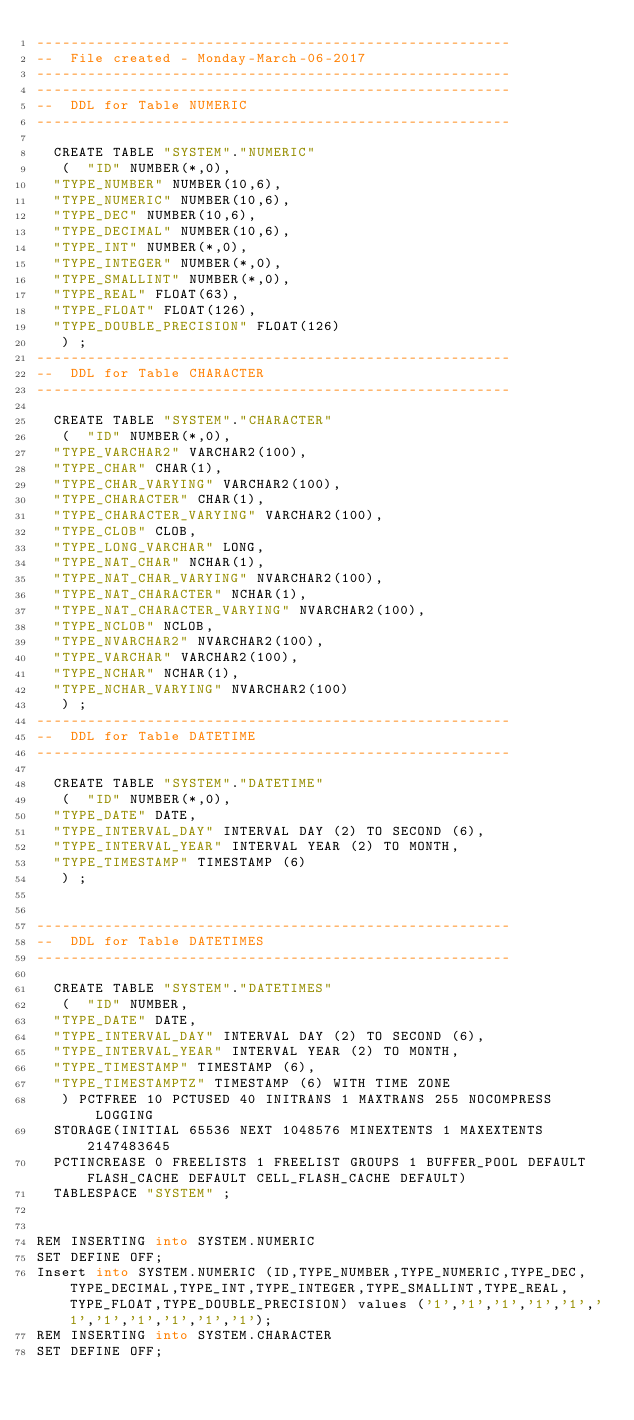<code> <loc_0><loc_0><loc_500><loc_500><_SQL_>--------------------------------------------------------
--  File created - Monday-March-06-2017   
--------------------------------------------------------
--------------------------------------------------------
--  DDL for Table NUMERIC
--------------------------------------------------------

  CREATE TABLE "SYSTEM"."NUMERIC" 
   (	"ID" NUMBER(*,0), 
	"TYPE_NUMBER" NUMBER(10,6), 
	"TYPE_NUMERIC" NUMBER(10,6), 
	"TYPE_DEC" NUMBER(10,6), 
	"TYPE_DECIMAL" NUMBER(10,6), 
	"TYPE_INT" NUMBER(*,0), 
	"TYPE_INTEGER" NUMBER(*,0), 
	"TYPE_SMALLINT" NUMBER(*,0), 
	"TYPE_REAL" FLOAT(63), 
	"TYPE_FLOAT" FLOAT(126), 
	"TYPE_DOUBLE_PRECISION" FLOAT(126)
   ) ;
--------------------------------------------------------
--  DDL for Table CHARACTER
--------------------------------------------------------

  CREATE TABLE "SYSTEM"."CHARACTER" 
   (	"ID" NUMBER(*,0), 
	"TYPE_VARCHAR2" VARCHAR2(100), 
	"TYPE_CHAR" CHAR(1), 
	"TYPE_CHAR_VARYING" VARCHAR2(100), 
	"TYPE_CHARACTER" CHAR(1), 
	"TYPE_CHARACTER_VARYING" VARCHAR2(100), 
	"TYPE_CLOB" CLOB, 
	"TYPE_LONG_VARCHAR" LONG, 
	"TYPE_NAT_CHAR" NCHAR(1), 
	"TYPE_NAT_CHAR_VARYING" NVARCHAR2(100), 
	"TYPE_NAT_CHARACTER" NCHAR(1), 
	"TYPE_NAT_CHARACTER_VARYING" NVARCHAR2(100), 
	"TYPE_NCLOB" NCLOB, 
	"TYPE_NVARCHAR2" NVARCHAR2(100), 
	"TYPE_VARCHAR" VARCHAR2(100), 
	"TYPE_NCHAR" NCHAR(1), 
	"TYPE_NCHAR_VARYING" NVARCHAR2(100)
   ) ;
--------------------------------------------------------
--  DDL for Table DATETIME
--------------------------------------------------------

  CREATE TABLE "SYSTEM"."DATETIME" 
   (	"ID" NUMBER(*,0), 
	"TYPE_DATE" DATE, 
	"TYPE_INTERVAL_DAY" INTERVAL DAY (2) TO SECOND (6), 
	"TYPE_INTERVAL_YEAR" INTERVAL YEAR (2) TO MONTH, 
	"TYPE_TIMESTAMP" TIMESTAMP (6)
   ) ;


--------------------------------------------------------
--  DDL for Table DATETIMES
--------------------------------------------------------

  CREATE TABLE "SYSTEM"."DATETIMES"
   (	"ID" NUMBER,
	"TYPE_DATE" DATE,
	"TYPE_INTERVAL_DAY" INTERVAL DAY (2) TO SECOND (6),
	"TYPE_INTERVAL_YEAR" INTERVAL YEAR (2) TO MONTH,
	"TYPE_TIMESTAMP" TIMESTAMP (6),
	"TYPE_TIMESTAMPTZ" TIMESTAMP (6) WITH TIME ZONE
   ) PCTFREE 10 PCTUSED 40 INITRANS 1 MAXTRANS 255 NOCOMPRESS LOGGING
  STORAGE(INITIAL 65536 NEXT 1048576 MINEXTENTS 1 MAXEXTENTS 2147483645
  PCTINCREASE 0 FREELISTS 1 FREELIST GROUPS 1 BUFFER_POOL DEFAULT FLASH_CACHE DEFAULT CELL_FLASH_CACHE DEFAULT)
  TABLESPACE "SYSTEM" ;


REM INSERTING into SYSTEM.NUMERIC
SET DEFINE OFF;
Insert into SYSTEM.NUMERIC (ID,TYPE_NUMBER,TYPE_NUMERIC,TYPE_DEC,TYPE_DECIMAL,TYPE_INT,TYPE_INTEGER,TYPE_SMALLINT,TYPE_REAL,TYPE_FLOAT,TYPE_DOUBLE_PRECISION) values ('1','1','1','1','1','1','1','1','1','1','1');
REM INSERTING into SYSTEM.CHARACTER
SET DEFINE OFF;</code> 